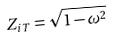<formula> <loc_0><loc_0><loc_500><loc_500>Z _ { i T } = \sqrt { 1 - \omega ^ { 2 } }</formula> 